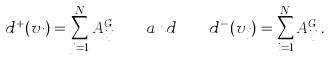<formula> <loc_0><loc_0><loc_500><loc_500>d ^ { + } ( v _ { i } ) = \sum _ { j = 1 } ^ { N } A ^ { G } _ { i j } \quad { a n d } \quad d ^ { - } ( v _ { j } ) = \sum _ { i = 1 } ^ { N } A ^ { G } _ { i j } \, .</formula> 